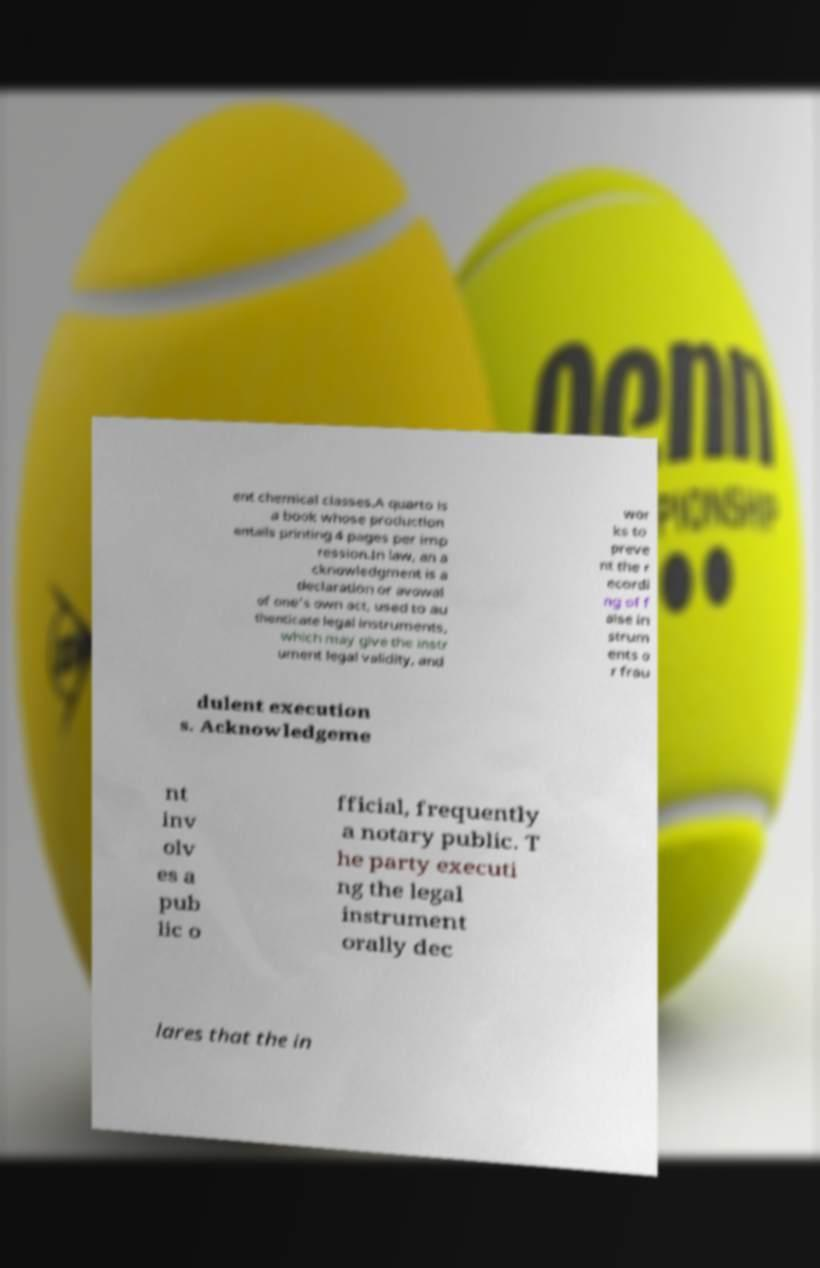Could you assist in decoding the text presented in this image and type it out clearly? ent chemical classes.A quarto is a book whose production entails printing 4 pages per imp ression.In law, an a cknowledgment is a declaration or avowal of one's own act, used to au thenticate legal instruments, which may give the instr ument legal validity, and wor ks to preve nt the r ecordi ng of f alse in strum ents o r frau dulent execution s. Acknowledgeme nt inv olv es a pub lic o fficial, frequently a notary public. T he party executi ng the legal instrument orally dec lares that the in 